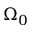<formula> <loc_0><loc_0><loc_500><loc_500>\Omega _ { 0 }</formula> 